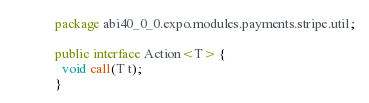<code> <loc_0><loc_0><loc_500><loc_500><_Java_>package abi40_0_0.expo.modules.payments.stripe.util;

public interface Action<T> {
  void call(T t);
}
</code> 